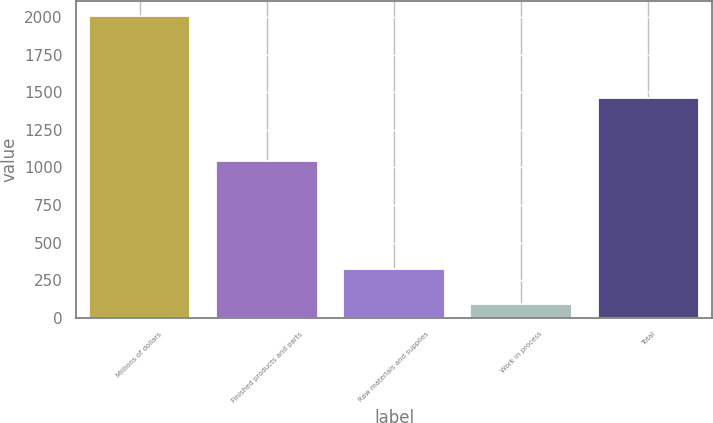Convert chart to OTSL. <chart><loc_0><loc_0><loc_500><loc_500><bar_chart><fcel>Millions of dollars<fcel>Finished products and parts<fcel>Raw materials and supplies<fcel>Work in process<fcel>Total<nl><fcel>2007<fcel>1042<fcel>325<fcel>92<fcel>1459<nl></chart> 